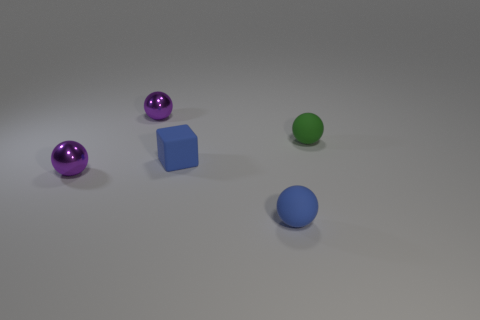Is there anything about these objects that suggests what material they might be made of? Yes, the two spheres on the left appear to have reflective, shiny surfaces that could indicate they are made of a polished metal or perhaps glass. The blue cube, with its more diffused and matte finish, might be constructed from a plastic or painted wood, while the green sphere has a similar matte finish, suggesting it could be made from a material like rubber or a non-shiny plastic. 